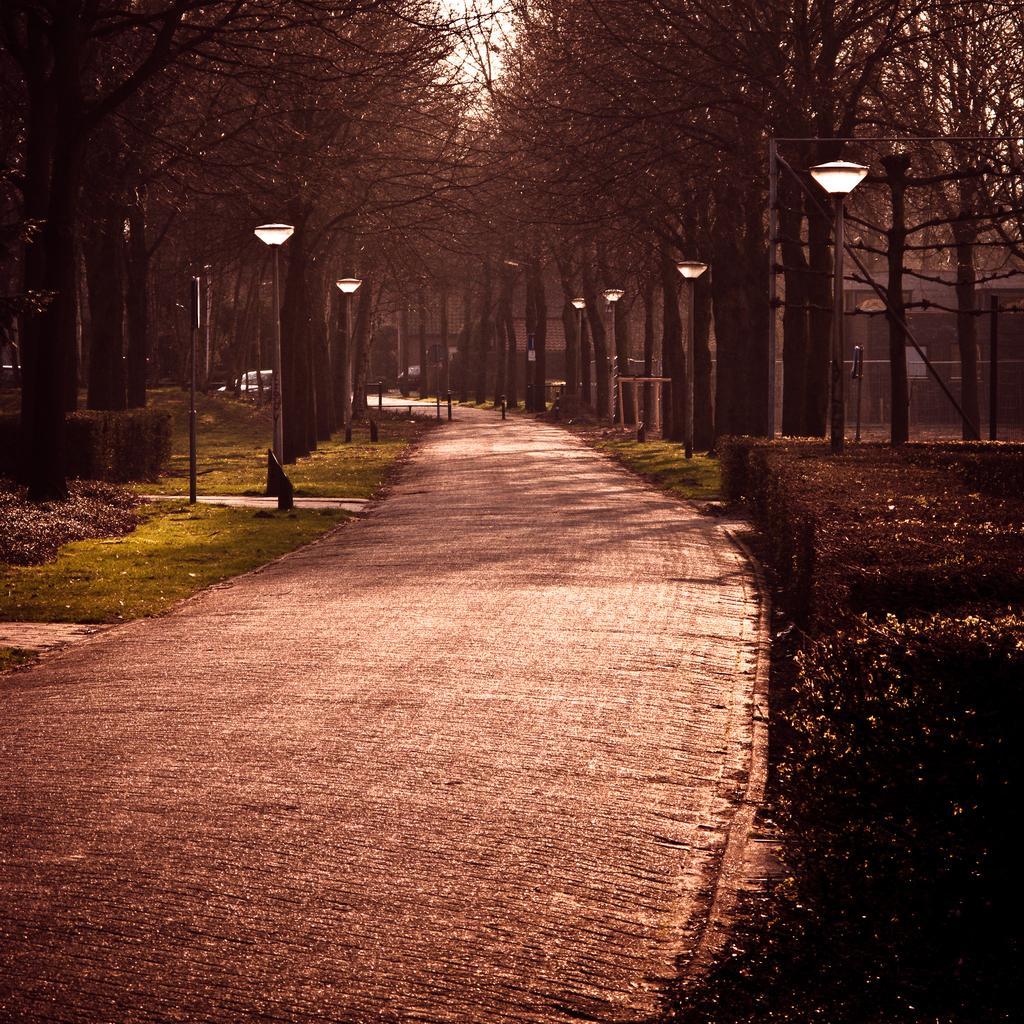In one or two sentences, can you explain what this image depicts? In this picture we can see poles, lights, grass, path and in the background we can see trees. 